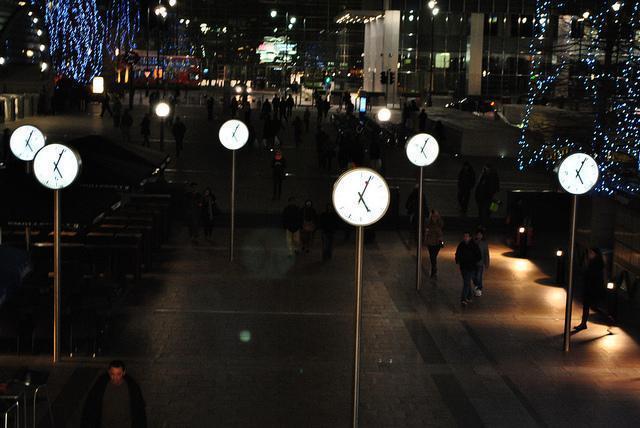Why are there blue lights on the trees?
Answer the question by selecting the correct answer among the 4 following choices.
Options: For racing, for climbing, for holiday, to signal. For holiday. 